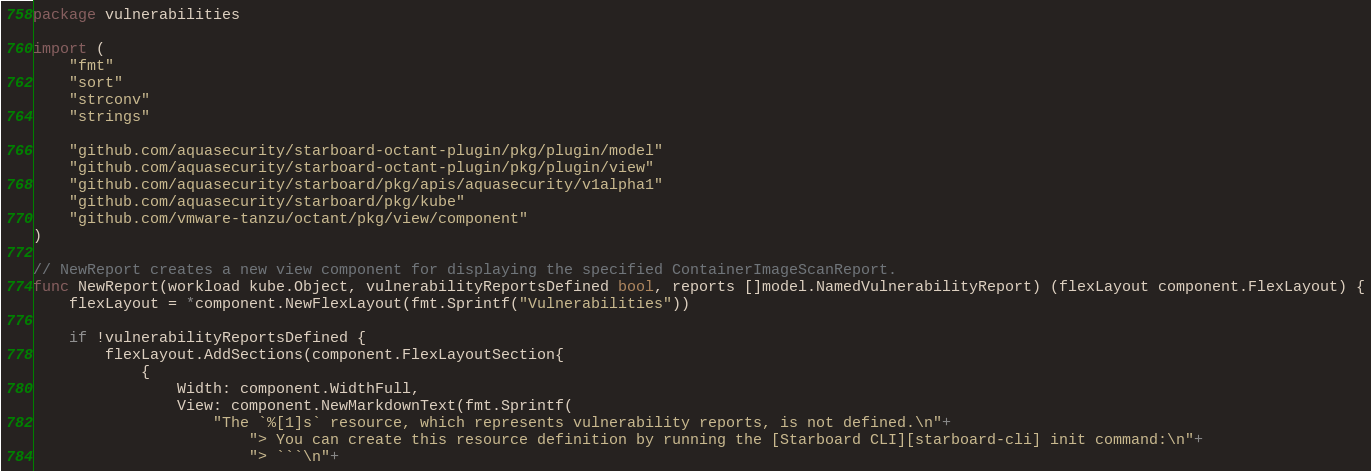<code> <loc_0><loc_0><loc_500><loc_500><_Go_>package vulnerabilities

import (
	"fmt"
	"sort"
	"strconv"
	"strings"

	"github.com/aquasecurity/starboard-octant-plugin/pkg/plugin/model"
	"github.com/aquasecurity/starboard-octant-plugin/pkg/plugin/view"
	"github.com/aquasecurity/starboard/pkg/apis/aquasecurity/v1alpha1"
	"github.com/aquasecurity/starboard/pkg/kube"
	"github.com/vmware-tanzu/octant/pkg/view/component"
)

// NewReport creates a new view component for displaying the specified ContainerImageScanReport.
func NewReport(workload kube.Object, vulnerabilityReportsDefined bool, reports []model.NamedVulnerabilityReport) (flexLayout component.FlexLayout) {
	flexLayout = *component.NewFlexLayout(fmt.Sprintf("Vulnerabilities"))

	if !vulnerabilityReportsDefined {
		flexLayout.AddSections(component.FlexLayoutSection{
			{
				Width: component.WidthFull,
				View: component.NewMarkdownText(fmt.Sprintf(
					"The `%[1]s` resource, which represents vulnerability reports, is not defined.\n"+
						"> You can create this resource definition by running the [Starboard CLI][starboard-cli] init command:\n"+
						"> ```\n"+</code> 